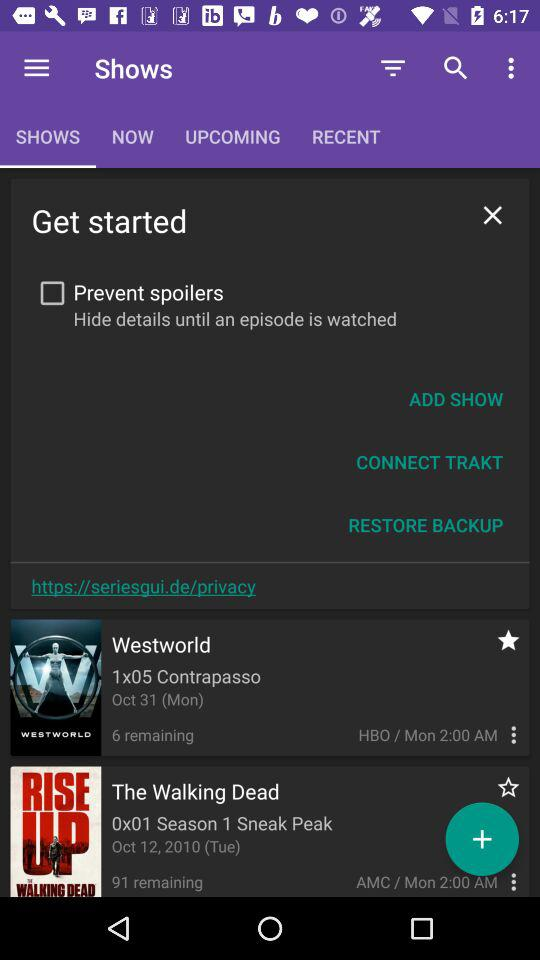How many episodes of "Westworld" are left to watch? There are 6 episodes of "Westworld" left to watch. 